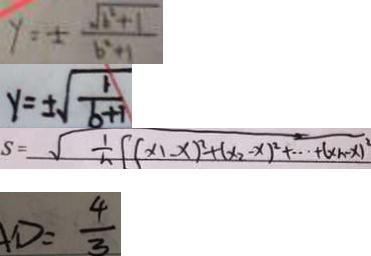<formula> <loc_0><loc_0><loc_500><loc_500>y = \pm \frac { \sqrt { b ^ { 2 } + 1 } } { b ^ { 2 } + 1 } 
 y = \pm \sqrt { \frac { 1 } { b + 1 } } 
 S = \sqrt { \frac { 1 } { n } [ ( x _ { 1 } - x ) ^ { 2 } + ( x _ { 2 } - x ) ^ { 2 } + \cdots + ( x _ { n } - x ) ^ { 2 } } 
 D = \frac { 4 } { 3 }</formula> 